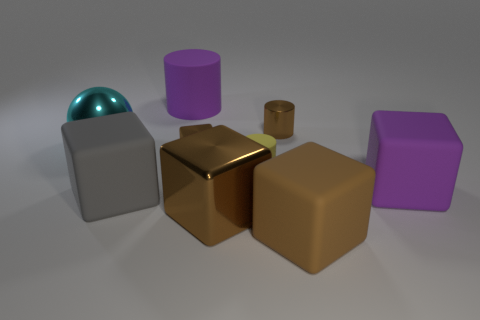Subtract all green spheres. How many brown blocks are left? 3 Subtract all cylinders. How many objects are left? 6 Add 4 big metal objects. How many big metal objects exist? 6 Subtract 0 blue spheres. How many objects are left? 9 Subtract all metal spheres. Subtract all cyan things. How many objects are left? 7 Add 7 large matte cylinders. How many large matte cylinders are left? 8 